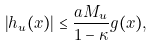Convert formula to latex. <formula><loc_0><loc_0><loc_500><loc_500>\left | h _ { u } ( x ) \right | \leq \frac { a M _ { u } } { 1 - \kappa } g ( x ) ,</formula> 